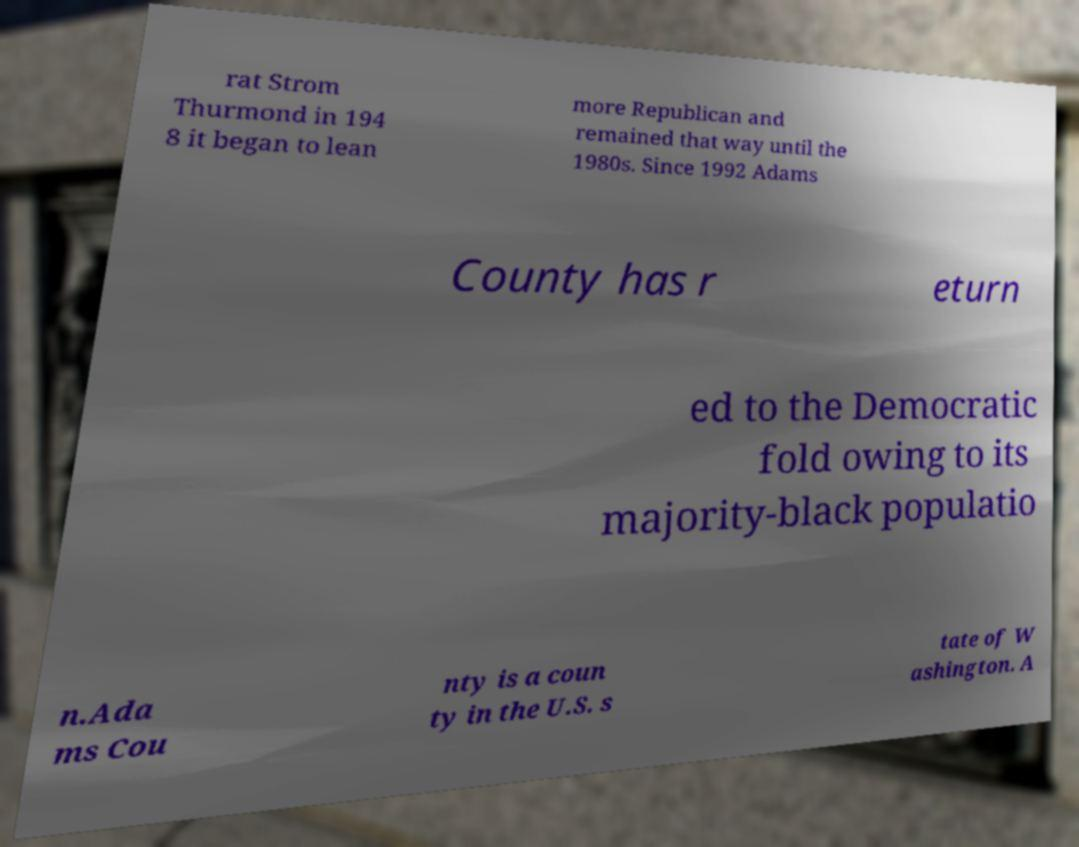Can you accurately transcribe the text from the provided image for me? rat Strom Thurmond in 194 8 it began to lean more Republican and remained that way until the 1980s. Since 1992 Adams County has r eturn ed to the Democratic fold owing to its majority-black populatio n.Ada ms Cou nty is a coun ty in the U.S. s tate of W ashington. A 